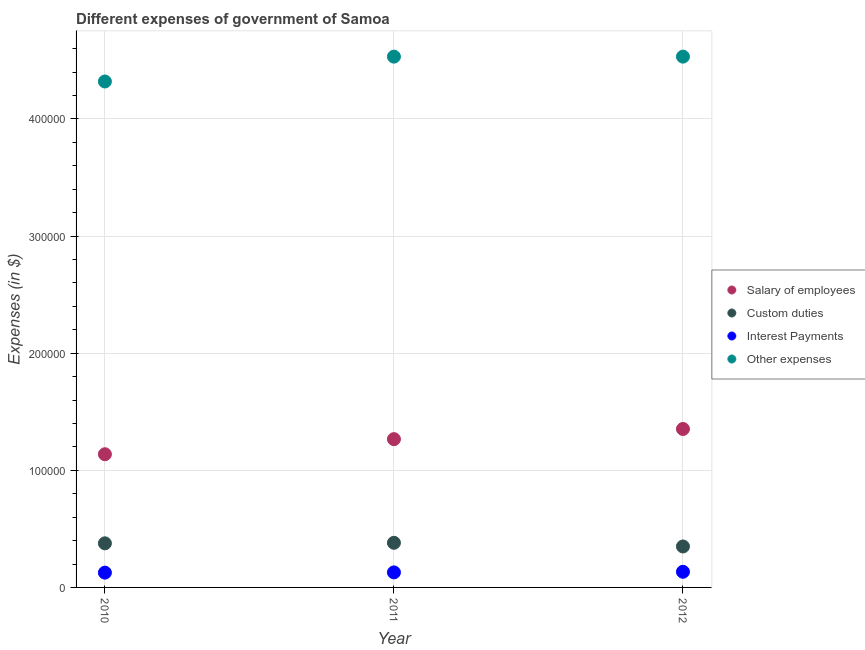What is the amount spent on custom duties in 2011?
Give a very brief answer. 3.81e+04. Across all years, what is the maximum amount spent on other expenses?
Keep it short and to the point. 4.53e+05. Across all years, what is the minimum amount spent on custom duties?
Offer a terse response. 3.50e+04. In which year was the amount spent on custom duties maximum?
Give a very brief answer. 2011. In which year was the amount spent on interest payments minimum?
Provide a short and direct response. 2010. What is the total amount spent on salary of employees in the graph?
Keep it short and to the point. 3.76e+05. What is the difference between the amount spent on salary of employees in 2011 and that in 2012?
Make the answer very short. -8666.97. What is the difference between the amount spent on other expenses in 2011 and the amount spent on interest payments in 2010?
Offer a very short reply. 4.41e+05. What is the average amount spent on other expenses per year?
Your response must be concise. 4.46e+05. In the year 2012, what is the difference between the amount spent on interest payments and amount spent on custom duties?
Provide a succinct answer. -2.16e+04. In how many years, is the amount spent on custom duties greater than 120000 $?
Ensure brevity in your answer.  0. What is the ratio of the amount spent on salary of employees in 2011 to that in 2012?
Your answer should be compact. 0.94. Is the difference between the amount spent on interest payments in 2011 and 2012 greater than the difference between the amount spent on salary of employees in 2011 and 2012?
Provide a succinct answer. Yes. What is the difference between the highest and the second highest amount spent on other expenses?
Your response must be concise. 5.38. What is the difference between the highest and the lowest amount spent on other expenses?
Provide a succinct answer. 2.12e+04. How many dotlines are there?
Your answer should be compact. 4. How many years are there in the graph?
Keep it short and to the point. 3. What is the difference between two consecutive major ticks on the Y-axis?
Offer a terse response. 1.00e+05. Does the graph contain any zero values?
Your answer should be very brief. No. Does the graph contain grids?
Keep it short and to the point. Yes. Where does the legend appear in the graph?
Offer a terse response. Center right. How many legend labels are there?
Ensure brevity in your answer.  4. What is the title of the graph?
Offer a very short reply. Different expenses of government of Samoa. Does "Tracking ability" appear as one of the legend labels in the graph?
Ensure brevity in your answer.  No. What is the label or title of the X-axis?
Offer a very short reply. Year. What is the label or title of the Y-axis?
Offer a very short reply. Expenses (in $). What is the Expenses (in $) in Salary of employees in 2010?
Your response must be concise. 1.14e+05. What is the Expenses (in $) of Custom duties in 2010?
Make the answer very short. 3.77e+04. What is the Expenses (in $) of Interest Payments in 2010?
Provide a short and direct response. 1.26e+04. What is the Expenses (in $) of Other expenses in 2010?
Provide a short and direct response. 4.32e+05. What is the Expenses (in $) in Salary of employees in 2011?
Provide a succinct answer. 1.27e+05. What is the Expenses (in $) of Custom duties in 2011?
Give a very brief answer. 3.81e+04. What is the Expenses (in $) in Interest Payments in 2011?
Provide a succinct answer. 1.28e+04. What is the Expenses (in $) of Other expenses in 2011?
Offer a terse response. 4.53e+05. What is the Expenses (in $) of Salary of employees in 2012?
Keep it short and to the point. 1.35e+05. What is the Expenses (in $) of Custom duties in 2012?
Make the answer very short. 3.50e+04. What is the Expenses (in $) in Interest Payments in 2012?
Offer a very short reply. 1.34e+04. What is the Expenses (in $) in Other expenses in 2012?
Your response must be concise. 4.53e+05. Across all years, what is the maximum Expenses (in $) of Salary of employees?
Your response must be concise. 1.35e+05. Across all years, what is the maximum Expenses (in $) in Custom duties?
Your answer should be compact. 3.81e+04. Across all years, what is the maximum Expenses (in $) of Interest Payments?
Keep it short and to the point. 1.34e+04. Across all years, what is the maximum Expenses (in $) in Other expenses?
Keep it short and to the point. 4.53e+05. Across all years, what is the minimum Expenses (in $) of Salary of employees?
Make the answer very short. 1.14e+05. Across all years, what is the minimum Expenses (in $) in Custom duties?
Make the answer very short. 3.50e+04. Across all years, what is the minimum Expenses (in $) in Interest Payments?
Keep it short and to the point. 1.26e+04. Across all years, what is the minimum Expenses (in $) in Other expenses?
Your response must be concise. 4.32e+05. What is the total Expenses (in $) of Salary of employees in the graph?
Make the answer very short. 3.76e+05. What is the total Expenses (in $) of Custom duties in the graph?
Offer a terse response. 1.11e+05. What is the total Expenses (in $) of Interest Payments in the graph?
Ensure brevity in your answer.  3.88e+04. What is the total Expenses (in $) of Other expenses in the graph?
Your response must be concise. 1.34e+06. What is the difference between the Expenses (in $) of Salary of employees in 2010 and that in 2011?
Give a very brief answer. -1.29e+04. What is the difference between the Expenses (in $) in Custom duties in 2010 and that in 2011?
Offer a terse response. -446.14. What is the difference between the Expenses (in $) of Interest Payments in 2010 and that in 2011?
Your response must be concise. -201.28. What is the difference between the Expenses (in $) in Other expenses in 2010 and that in 2011?
Your response must be concise. -2.12e+04. What is the difference between the Expenses (in $) of Salary of employees in 2010 and that in 2012?
Give a very brief answer. -2.16e+04. What is the difference between the Expenses (in $) of Custom duties in 2010 and that in 2012?
Your answer should be compact. 2691.4. What is the difference between the Expenses (in $) of Interest Payments in 2010 and that in 2012?
Your answer should be compact. -732.78. What is the difference between the Expenses (in $) in Other expenses in 2010 and that in 2012?
Your response must be concise. -2.12e+04. What is the difference between the Expenses (in $) of Salary of employees in 2011 and that in 2012?
Ensure brevity in your answer.  -8666.97. What is the difference between the Expenses (in $) in Custom duties in 2011 and that in 2012?
Your response must be concise. 3137.54. What is the difference between the Expenses (in $) in Interest Payments in 2011 and that in 2012?
Provide a succinct answer. -531.5. What is the difference between the Expenses (in $) of Other expenses in 2011 and that in 2012?
Your answer should be compact. -5.38. What is the difference between the Expenses (in $) in Salary of employees in 2010 and the Expenses (in $) in Custom duties in 2011?
Offer a very short reply. 7.56e+04. What is the difference between the Expenses (in $) in Salary of employees in 2010 and the Expenses (in $) in Interest Payments in 2011?
Offer a terse response. 1.01e+05. What is the difference between the Expenses (in $) in Salary of employees in 2010 and the Expenses (in $) in Other expenses in 2011?
Offer a very short reply. -3.40e+05. What is the difference between the Expenses (in $) of Custom duties in 2010 and the Expenses (in $) of Interest Payments in 2011?
Your answer should be compact. 2.48e+04. What is the difference between the Expenses (in $) in Custom duties in 2010 and the Expenses (in $) in Other expenses in 2011?
Make the answer very short. -4.16e+05. What is the difference between the Expenses (in $) in Interest Payments in 2010 and the Expenses (in $) in Other expenses in 2011?
Offer a terse response. -4.41e+05. What is the difference between the Expenses (in $) of Salary of employees in 2010 and the Expenses (in $) of Custom duties in 2012?
Your answer should be very brief. 7.88e+04. What is the difference between the Expenses (in $) in Salary of employees in 2010 and the Expenses (in $) in Interest Payments in 2012?
Give a very brief answer. 1.00e+05. What is the difference between the Expenses (in $) of Salary of employees in 2010 and the Expenses (in $) of Other expenses in 2012?
Your answer should be compact. -3.40e+05. What is the difference between the Expenses (in $) of Custom duties in 2010 and the Expenses (in $) of Interest Payments in 2012?
Provide a succinct answer. 2.43e+04. What is the difference between the Expenses (in $) in Custom duties in 2010 and the Expenses (in $) in Other expenses in 2012?
Your answer should be compact. -4.16e+05. What is the difference between the Expenses (in $) of Interest Payments in 2010 and the Expenses (in $) of Other expenses in 2012?
Your response must be concise. -4.41e+05. What is the difference between the Expenses (in $) in Salary of employees in 2011 and the Expenses (in $) in Custom duties in 2012?
Give a very brief answer. 9.17e+04. What is the difference between the Expenses (in $) in Salary of employees in 2011 and the Expenses (in $) in Interest Payments in 2012?
Offer a terse response. 1.13e+05. What is the difference between the Expenses (in $) of Salary of employees in 2011 and the Expenses (in $) of Other expenses in 2012?
Make the answer very short. -3.27e+05. What is the difference between the Expenses (in $) in Custom duties in 2011 and the Expenses (in $) in Interest Payments in 2012?
Provide a succinct answer. 2.47e+04. What is the difference between the Expenses (in $) of Custom duties in 2011 and the Expenses (in $) of Other expenses in 2012?
Offer a very short reply. -4.15e+05. What is the difference between the Expenses (in $) in Interest Payments in 2011 and the Expenses (in $) in Other expenses in 2012?
Give a very brief answer. -4.40e+05. What is the average Expenses (in $) of Salary of employees per year?
Offer a very short reply. 1.25e+05. What is the average Expenses (in $) of Custom duties per year?
Your answer should be very brief. 3.69e+04. What is the average Expenses (in $) in Interest Payments per year?
Offer a terse response. 1.29e+04. What is the average Expenses (in $) in Other expenses per year?
Provide a succinct answer. 4.46e+05. In the year 2010, what is the difference between the Expenses (in $) of Salary of employees and Expenses (in $) of Custom duties?
Keep it short and to the point. 7.61e+04. In the year 2010, what is the difference between the Expenses (in $) in Salary of employees and Expenses (in $) in Interest Payments?
Ensure brevity in your answer.  1.01e+05. In the year 2010, what is the difference between the Expenses (in $) in Salary of employees and Expenses (in $) in Other expenses?
Provide a succinct answer. -3.18e+05. In the year 2010, what is the difference between the Expenses (in $) in Custom duties and Expenses (in $) in Interest Payments?
Keep it short and to the point. 2.50e+04. In the year 2010, what is the difference between the Expenses (in $) of Custom duties and Expenses (in $) of Other expenses?
Offer a very short reply. -3.94e+05. In the year 2010, what is the difference between the Expenses (in $) of Interest Payments and Expenses (in $) of Other expenses?
Offer a terse response. -4.19e+05. In the year 2011, what is the difference between the Expenses (in $) of Salary of employees and Expenses (in $) of Custom duties?
Offer a terse response. 8.85e+04. In the year 2011, what is the difference between the Expenses (in $) in Salary of employees and Expenses (in $) in Interest Payments?
Make the answer very short. 1.14e+05. In the year 2011, what is the difference between the Expenses (in $) of Salary of employees and Expenses (in $) of Other expenses?
Your answer should be very brief. -3.27e+05. In the year 2011, what is the difference between the Expenses (in $) in Custom duties and Expenses (in $) in Interest Payments?
Your answer should be very brief. 2.53e+04. In the year 2011, what is the difference between the Expenses (in $) in Custom duties and Expenses (in $) in Other expenses?
Offer a very short reply. -4.15e+05. In the year 2011, what is the difference between the Expenses (in $) of Interest Payments and Expenses (in $) of Other expenses?
Your answer should be compact. -4.40e+05. In the year 2012, what is the difference between the Expenses (in $) of Salary of employees and Expenses (in $) of Custom duties?
Offer a very short reply. 1.00e+05. In the year 2012, what is the difference between the Expenses (in $) in Salary of employees and Expenses (in $) in Interest Payments?
Provide a short and direct response. 1.22e+05. In the year 2012, what is the difference between the Expenses (in $) in Salary of employees and Expenses (in $) in Other expenses?
Your answer should be compact. -3.18e+05. In the year 2012, what is the difference between the Expenses (in $) of Custom duties and Expenses (in $) of Interest Payments?
Give a very brief answer. 2.16e+04. In the year 2012, what is the difference between the Expenses (in $) of Custom duties and Expenses (in $) of Other expenses?
Give a very brief answer. -4.18e+05. In the year 2012, what is the difference between the Expenses (in $) of Interest Payments and Expenses (in $) of Other expenses?
Give a very brief answer. -4.40e+05. What is the ratio of the Expenses (in $) in Salary of employees in 2010 to that in 2011?
Your answer should be very brief. 0.9. What is the ratio of the Expenses (in $) of Custom duties in 2010 to that in 2011?
Your answer should be very brief. 0.99. What is the ratio of the Expenses (in $) in Interest Payments in 2010 to that in 2011?
Give a very brief answer. 0.98. What is the ratio of the Expenses (in $) of Other expenses in 2010 to that in 2011?
Ensure brevity in your answer.  0.95. What is the ratio of the Expenses (in $) of Salary of employees in 2010 to that in 2012?
Provide a succinct answer. 0.84. What is the ratio of the Expenses (in $) of Custom duties in 2010 to that in 2012?
Ensure brevity in your answer.  1.08. What is the ratio of the Expenses (in $) in Interest Payments in 2010 to that in 2012?
Offer a terse response. 0.95. What is the ratio of the Expenses (in $) of Other expenses in 2010 to that in 2012?
Keep it short and to the point. 0.95. What is the ratio of the Expenses (in $) in Salary of employees in 2011 to that in 2012?
Your answer should be compact. 0.94. What is the ratio of the Expenses (in $) of Custom duties in 2011 to that in 2012?
Keep it short and to the point. 1.09. What is the ratio of the Expenses (in $) in Interest Payments in 2011 to that in 2012?
Your answer should be compact. 0.96. What is the difference between the highest and the second highest Expenses (in $) in Salary of employees?
Ensure brevity in your answer.  8666.97. What is the difference between the highest and the second highest Expenses (in $) in Custom duties?
Provide a short and direct response. 446.14. What is the difference between the highest and the second highest Expenses (in $) of Interest Payments?
Your answer should be compact. 531.5. What is the difference between the highest and the second highest Expenses (in $) of Other expenses?
Provide a short and direct response. 5.38. What is the difference between the highest and the lowest Expenses (in $) of Salary of employees?
Make the answer very short. 2.16e+04. What is the difference between the highest and the lowest Expenses (in $) in Custom duties?
Ensure brevity in your answer.  3137.54. What is the difference between the highest and the lowest Expenses (in $) in Interest Payments?
Keep it short and to the point. 732.78. What is the difference between the highest and the lowest Expenses (in $) in Other expenses?
Offer a very short reply. 2.12e+04. 